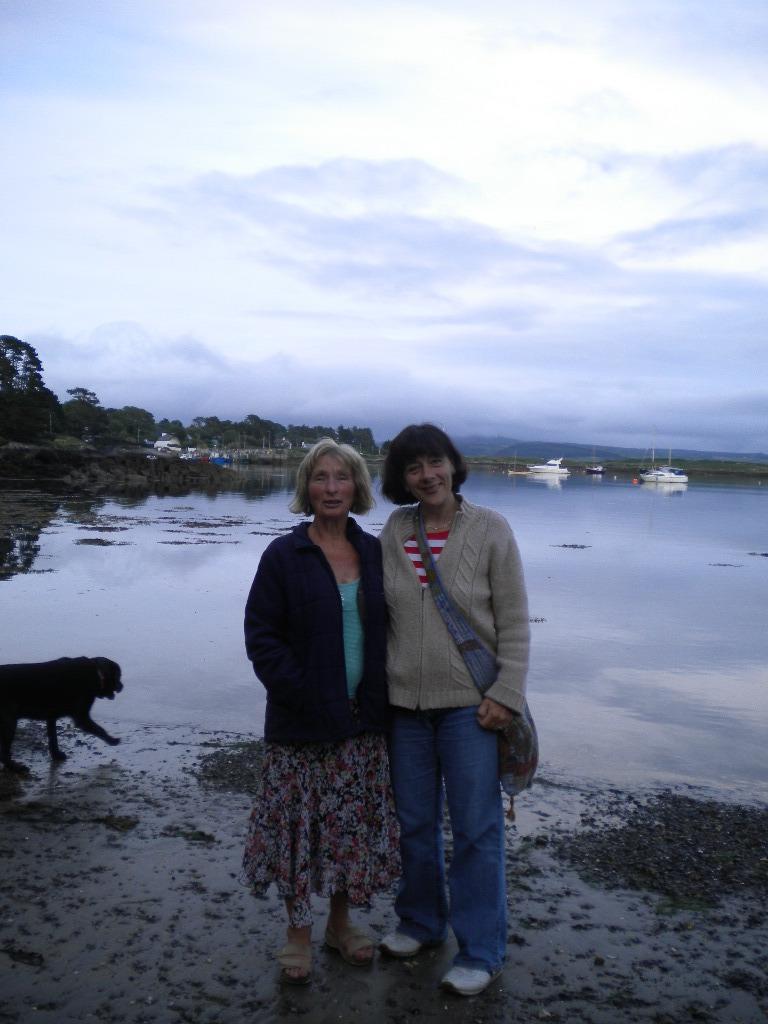Can you describe this image briefly? In this image I can see two women wearing jackets are standing and I can see one of them is wearing a bag. I can see a black colored animal, the water, few boats on the surface of the water and few trees. In the background I can see the sky. 